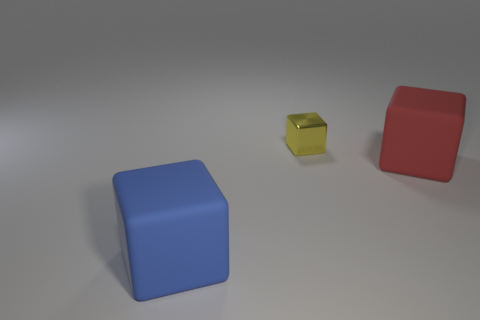There is a large cube that is behind the rubber block on the left side of the shiny block; are there any large red rubber things on the left side of it?
Offer a very short reply. No. The other blue object that is the same shape as the small thing is what size?
Keep it short and to the point. Large. Is there any other thing that has the same material as the large blue cube?
Provide a short and direct response. Yes. Are any big red matte cubes visible?
Ensure brevity in your answer.  Yes. Does the metal thing have the same color as the large object that is on the left side of the red matte block?
Provide a short and direct response. No. There is a matte block that is to the left of the large object that is on the right side of the big rubber block on the left side of the tiny block; what size is it?
Offer a very short reply. Large. How many objects are metal blocks or big rubber blocks in front of the yellow block?
Your response must be concise. 3. What is the color of the tiny cube?
Your answer should be compact. Yellow. What is the color of the matte block that is right of the metallic object?
Provide a succinct answer. Red. How many large cubes are left of the large block that is on the right side of the big blue object?
Offer a very short reply. 1. 